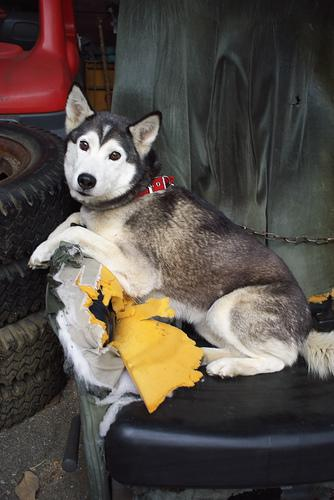Question: how many tires are stacked?
Choices:
A. Five.
B. Four.
C. Six.
D. Eight.
Answer with the letter. Answer: B Question: who is sitting in the chair?
Choices:
A. The dog.
B. A child.
C. A grandma.
D. A cat.
Answer with the letter. Answer: A Question: how many people are in this picture?
Choices:
A. One.
B. Zero.
C. Two.
D. Five.
Answer with the letter. Answer: B Question: what kind of animal is in the picture?
Choices:
A. A dog.
B. A horse.
C. A duck.
D. A playpus.
Answer with the letter. Answer: A 